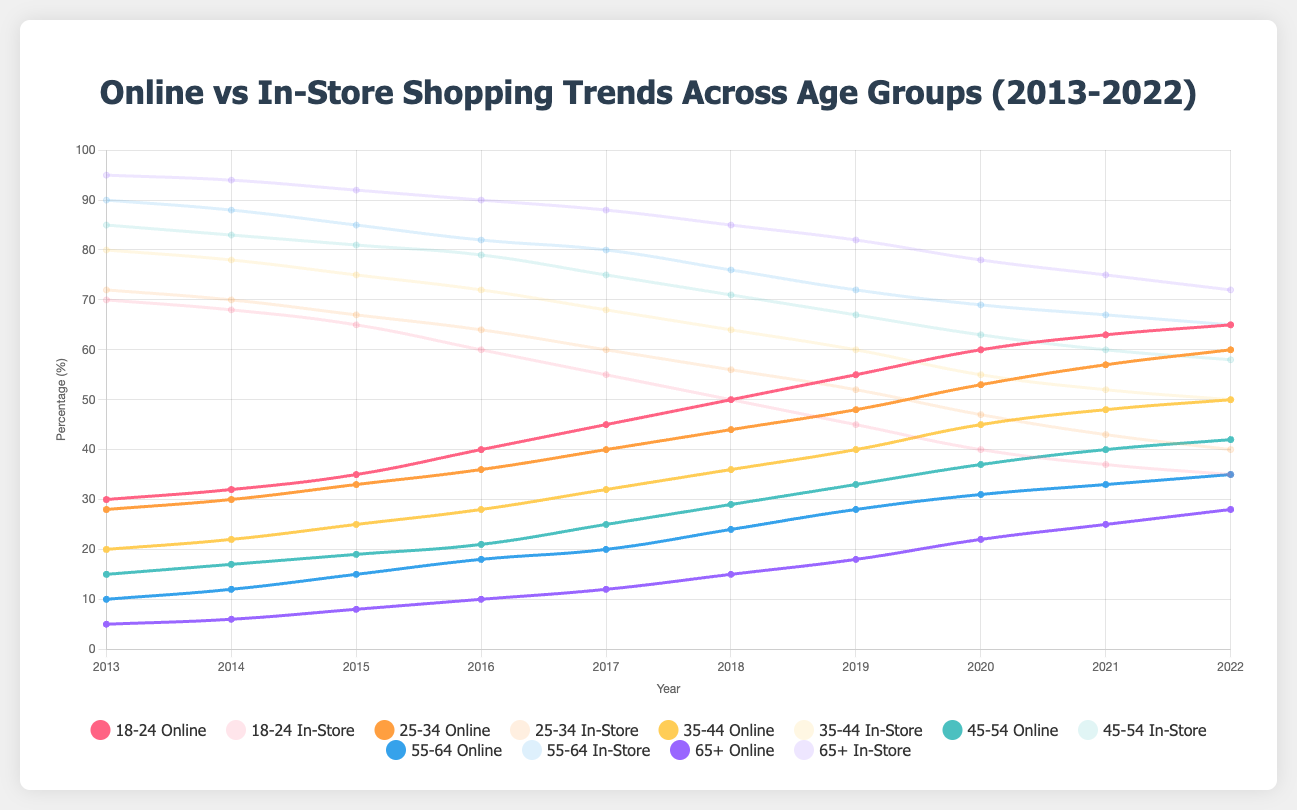What trend do you observe for online shopping among the 18-24 age group from 2013 to 2022? By looking at the line representing the 18-24 age group for online shopping, it starts at 30% in 2013 and gradually increases each year until it reaches 65% in 2022. This suggests a consistent upward trend in online shopping among the 18-24 age group over the decade.
Answer: Increasing trend In 2020, which age group had the highest percentage of online shopping? By inspecting the lines for online shopping in 2020, the 18-24 age group had the highest percentage at 60%.
Answer: 18-24 How did the in-store shopping preference change for the 55-64 age group from 2013 to 2022? Observing the line plot for in-store shopping among the 55-64 age group, it started at 90% in 2013 and declined to 65% by 2022, indicating a steady decrease over the decade.
Answer: Decreasing trend Between the 35-44 and 45-54 age groups, which one has a greater decline in in-store shopping from 2013 to 2022? For the 35-44 age group, in-store shopping declined from 80% to 50%, a 30 percentage point decrease. For the 45-54 age group, it declined from 85% to 58%, a 27 percentage point decrease. Therefore, the 35-44 age group had a greater decline.
Answer: 35-44 What is the difference in online shopping percentages between the 25-34 and 45-54 age groups in 2017? In 2017, the online shopping percentage for the 25-34 age group was 40%, and for the 45-54 age group, it was 25%. The difference is 40% - 25% = 15%.
Answer: 15% Which age group had the smallest increase in online shopping from 2013 to 2022? Examining the plot for online shopping increases, the 65+ age group had the smallest increase from 5% in 2013 to 28% in 2022, a 23 percentage point increase.
Answer: 65+ How does the online shopping trend for the 55-64 age group compare to the 35-44 age group over the decade? The 55-64 age group's online shopping increased from 10% in 2013 to 35% in 2022, while the 35-44 age group's online shopping increased from 20% to 50% in the same period. Both experienced an increasing trend, but the 35-44 age group had a higher overall growth.
Answer: Both increasing, but 35-44 more What is the average percentage of in-store shopping for the 18-24 age group over the decade? The in-store shopping percentages for the 18-24 age group over the years are [70, 68, 65, 60, 55, 50, 45, 40, 37, 35]. Adding these, the sum is 525. The average is 525/10 = 52.5%.
Answer: 52.5% Which visual attributes allow you to distinguish online shopping preferences for the different age groups? The visual attributes such as the color and position of lines on the graph distinguish the online shopping preferences. Each age group's online shopping trend is represented by a distinct color, and their position (height) on the y-axis shows the percentages.
Answer: Color and height of lines In which year do all the age groups show a more significant increase in online shopping? Examining the plot for noticeable changes, in 2020, most age groups show a significant increase in online shopping percentages, likely due to external factors such as the pandemic.
Answer: 2020 